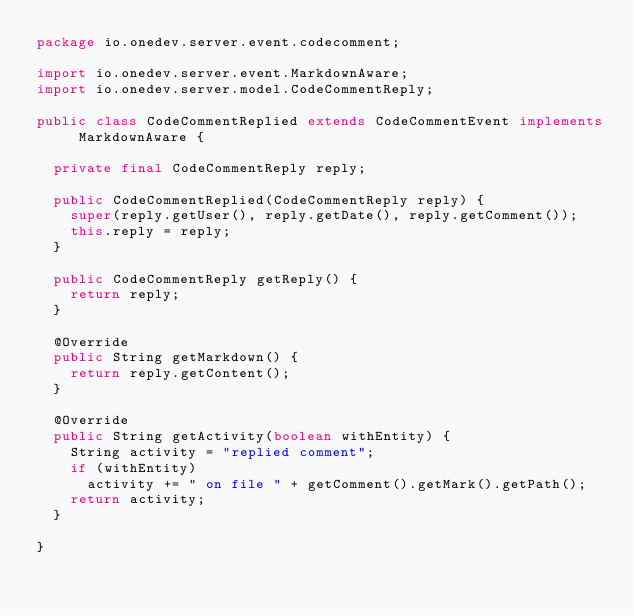<code> <loc_0><loc_0><loc_500><loc_500><_Java_>package io.onedev.server.event.codecomment;

import io.onedev.server.event.MarkdownAware;
import io.onedev.server.model.CodeCommentReply;

public class CodeCommentReplied extends CodeCommentEvent implements MarkdownAware {

	private final CodeCommentReply reply;
	
	public CodeCommentReplied(CodeCommentReply reply) {
		super(reply.getUser(), reply.getDate(), reply.getComment());
		this.reply = reply;
	}

	public CodeCommentReply getReply() {
		return reply;
	}

	@Override
	public String getMarkdown() {
		return reply.getContent();
	}

	@Override
	public String getActivity(boolean withEntity) {
		String activity = "replied comment";
		if (withEntity)
			activity += " on file " + getComment().getMark().getPath();
		return activity;
	}

}
</code> 